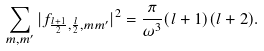Convert formula to latex. <formula><loc_0><loc_0><loc_500><loc_500>\sum _ { m , m ^ { \prime } } | f _ { \frac { l + 1 } { 2 } , \frac { l } { 2 } , m m ^ { \prime } } | ^ { 2 } = \frac { \pi } { \omega ^ { 3 } } ( l + 1 ) ( l + 2 ) .</formula> 